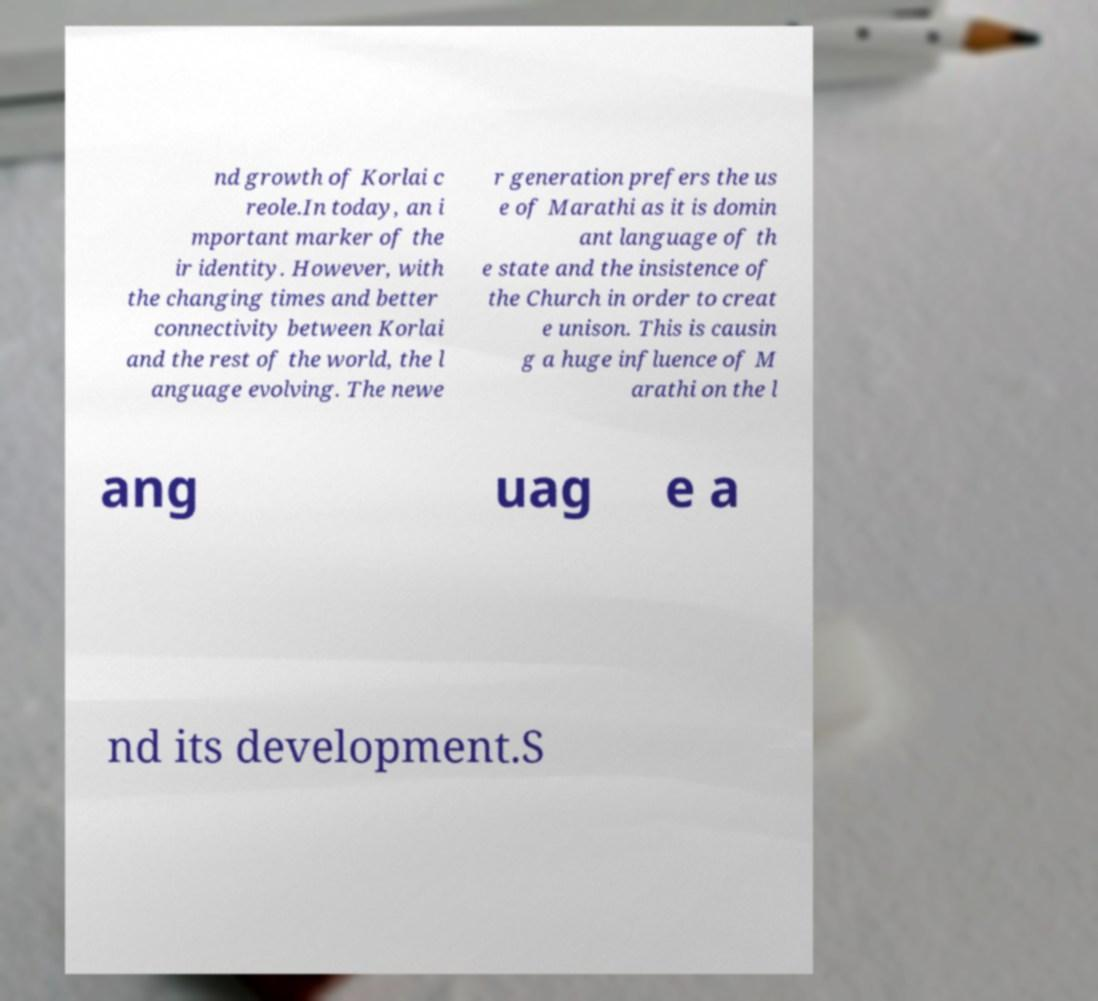Can you read and provide the text displayed in the image?This photo seems to have some interesting text. Can you extract and type it out for me? nd growth of Korlai c reole.In today, an i mportant marker of the ir identity. However, with the changing times and better connectivity between Korlai and the rest of the world, the l anguage evolving. The newe r generation prefers the us e of Marathi as it is domin ant language of th e state and the insistence of the Church in order to creat e unison. This is causin g a huge influence of M arathi on the l ang uag e a nd its development.S 